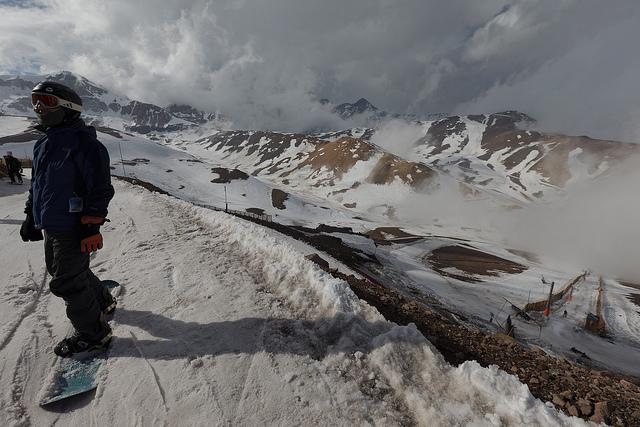What sport was this person most recently doing?
Give a very brief answer. Snowboarding. Is it a cloudy day?
Keep it brief. Yes. Is the person next to a beach?
Concise answer only. No. Are the mountains high?
Write a very short answer. Yes. Is the person wearing gloves?
Give a very brief answer. Yes. How many snowboarders are shown?
Be succinct. 1. 